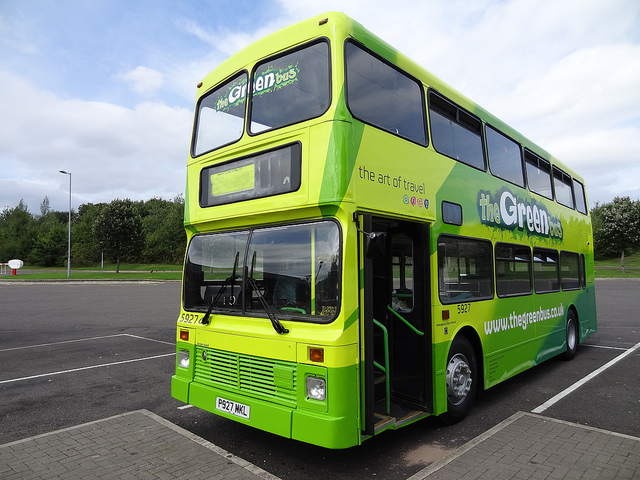Read and extract the text from this image. the art of travel 5927 www.thegreenbus.co 5927 MKL P927 bus Green the bus Green the 